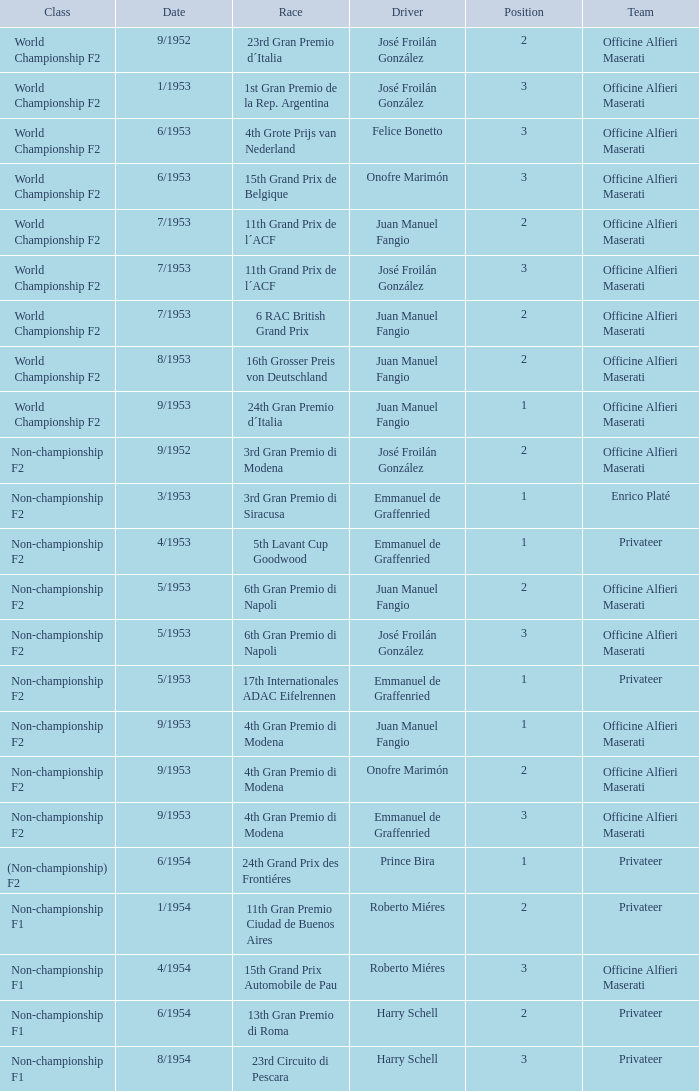What date has the class of non-championship f2 as well as a driver name josé froilán gonzález that has a position larger than 2? 5/1953. 